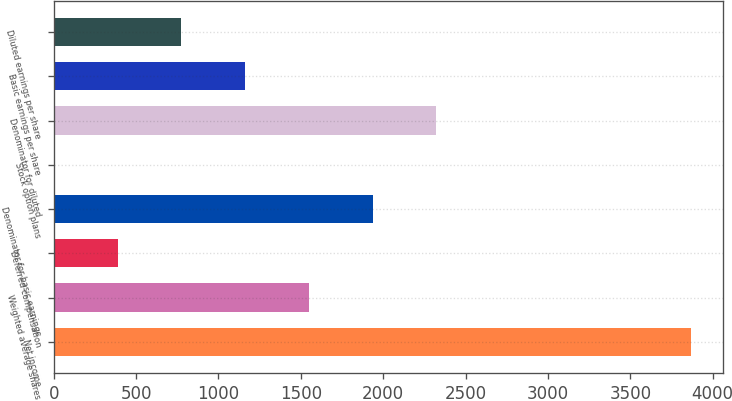Convert chart to OTSL. <chart><loc_0><loc_0><loc_500><loc_500><bar_chart><fcel>Net income<fcel>Weighted average shares<fcel>Deferred compensation<fcel>Denominator for basic earnings<fcel>Stock option plans<fcel>Denominator for diluted<fcel>Basic earnings per share<fcel>Diluted earnings per share<nl><fcel>3870<fcel>1549.2<fcel>388.8<fcel>1936<fcel>2<fcel>2322.8<fcel>1162.4<fcel>775.6<nl></chart> 